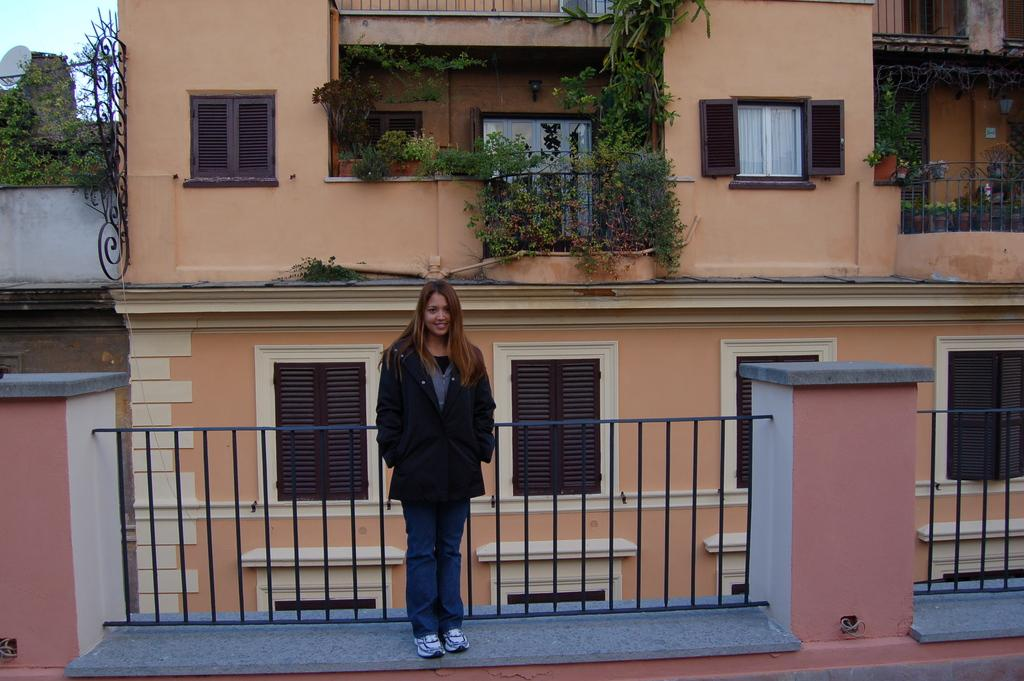What is the woman doing in the image? The woman is standing on the floor and leaning on railings in the image. What can be seen in the background of the image? Buildings, plants, creepers, windows, and the sky are visible in the background of the image. What arithmetic problem is the woman solving in the image? There is no indication in the image that the woman is solving an arithmetic problem. Who is the owner of the building in the background of the image? The image does not provide information about the ownership of the building in the background. 